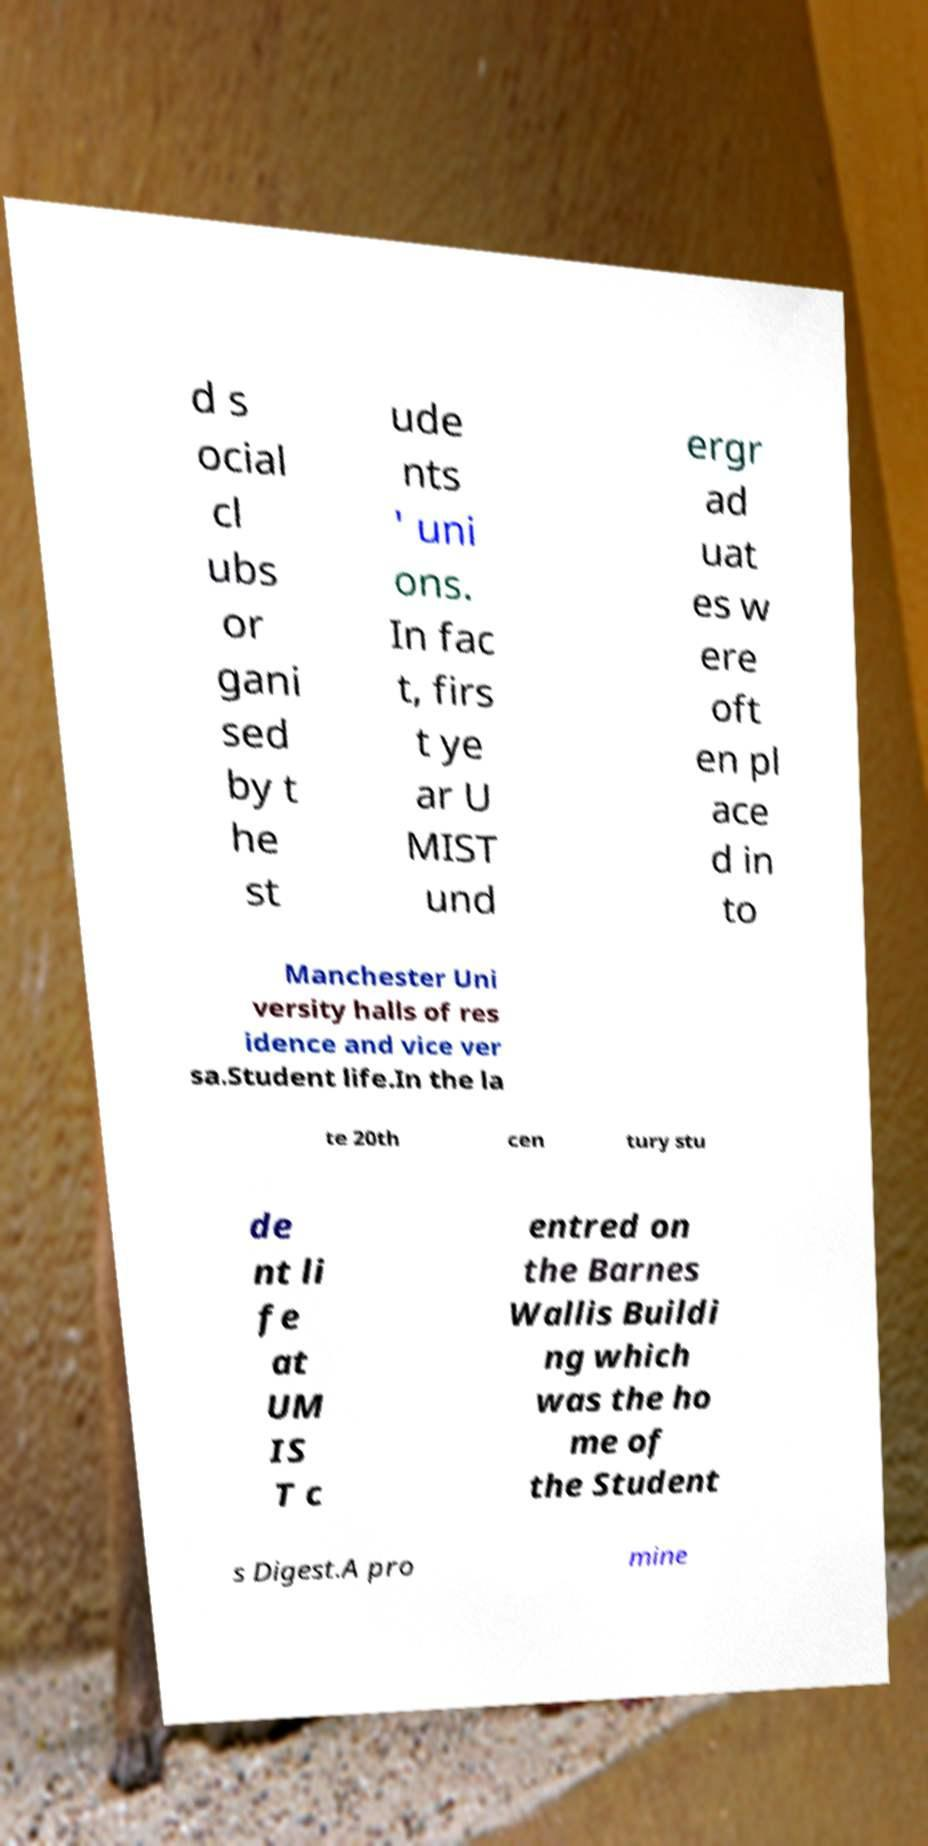What messages or text are displayed in this image? I need them in a readable, typed format. d s ocial cl ubs or gani sed by t he st ude nts ' uni ons. In fac t, firs t ye ar U MIST und ergr ad uat es w ere oft en pl ace d in to Manchester Uni versity halls of res idence and vice ver sa.Student life.In the la te 20th cen tury stu de nt li fe at UM IS T c entred on the Barnes Wallis Buildi ng which was the ho me of the Student s Digest.A pro mine 